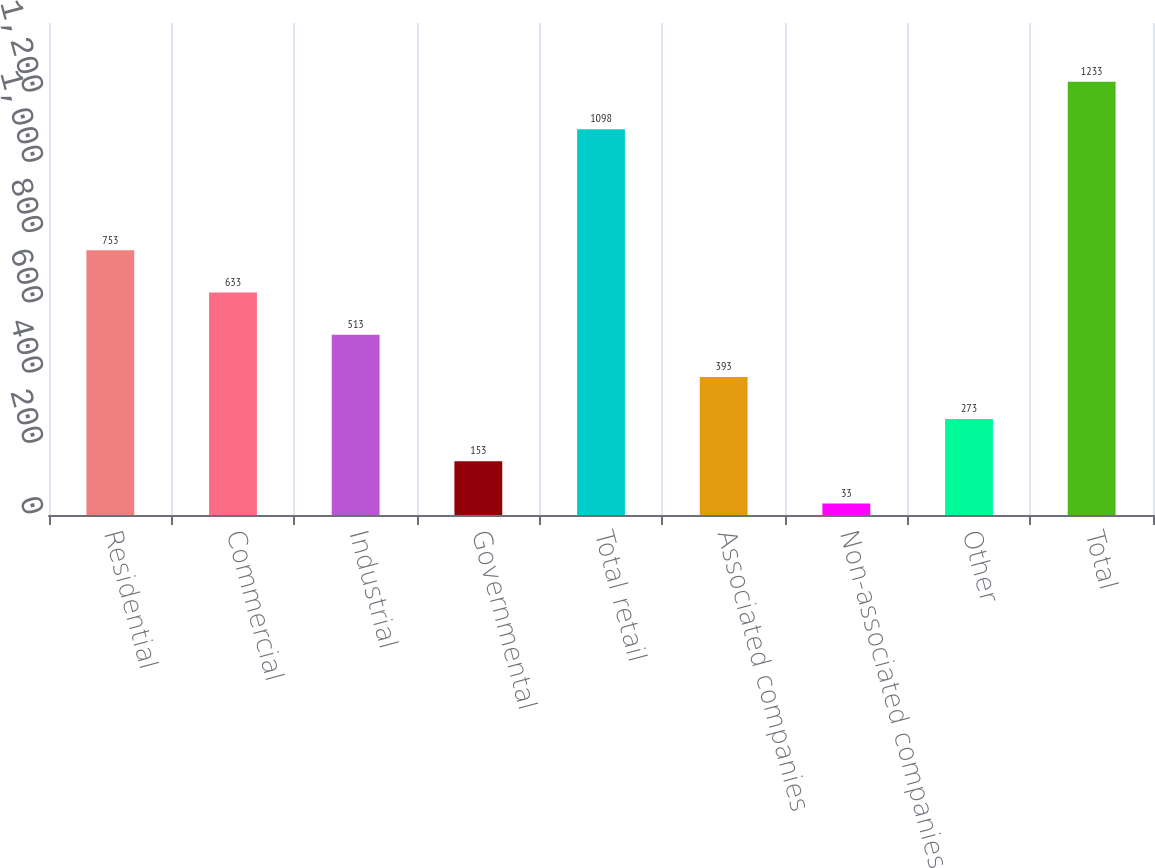<chart> <loc_0><loc_0><loc_500><loc_500><bar_chart><fcel>Residential<fcel>Commercial<fcel>Industrial<fcel>Governmental<fcel>Total retail<fcel>Associated companies<fcel>Non-associated companies<fcel>Other<fcel>Total<nl><fcel>753<fcel>633<fcel>513<fcel>153<fcel>1098<fcel>393<fcel>33<fcel>273<fcel>1233<nl></chart> 